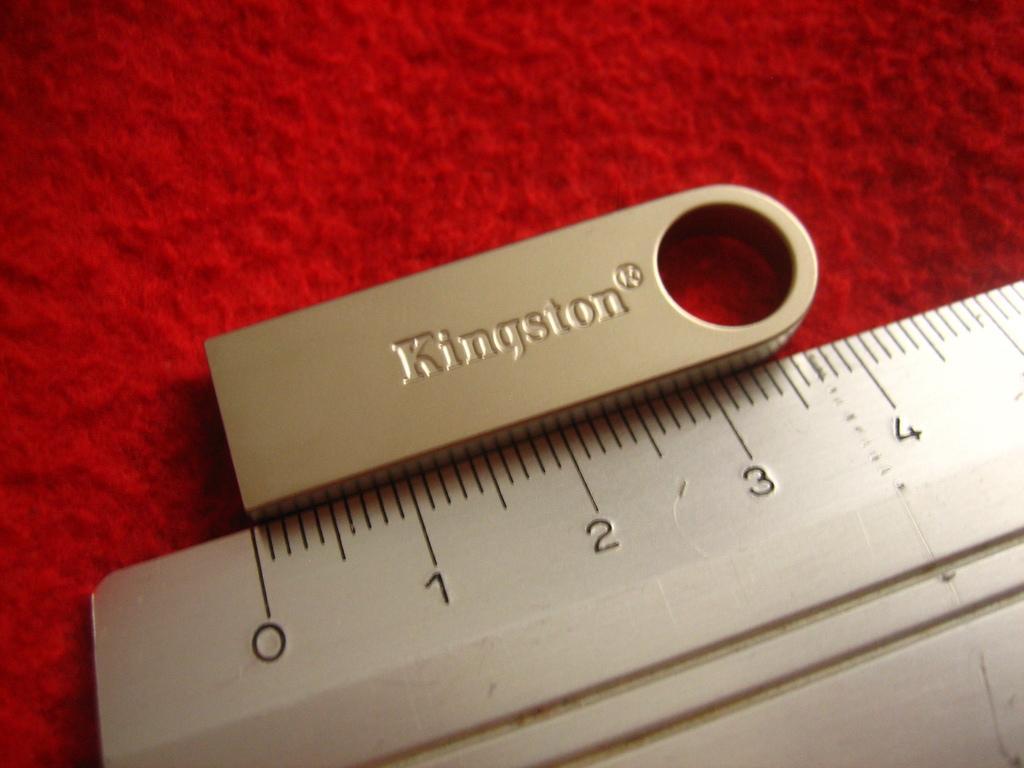In one or two sentences, can you explain what this image depicts? In this image, we can see a measuring scale with lines and numerical numbers. Here we can see a silver object. These objects are placed on the red surface. 